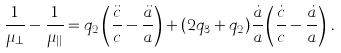<formula> <loc_0><loc_0><loc_500><loc_500>\frac { 1 } { \mu _ { \bot } } - \frac { 1 } { \mu _ { | | } } = q _ { 2 } \left ( \frac { \ddot { c } } { c } - \frac { \ddot { a } } { a } \right ) + ( 2 q _ { 3 } + q _ { 2 } ) \frac { \dot { a } } { a } \left ( \frac { \dot { c } } { c } - \frac { \dot { a } } { a } \right ) \, .</formula> 